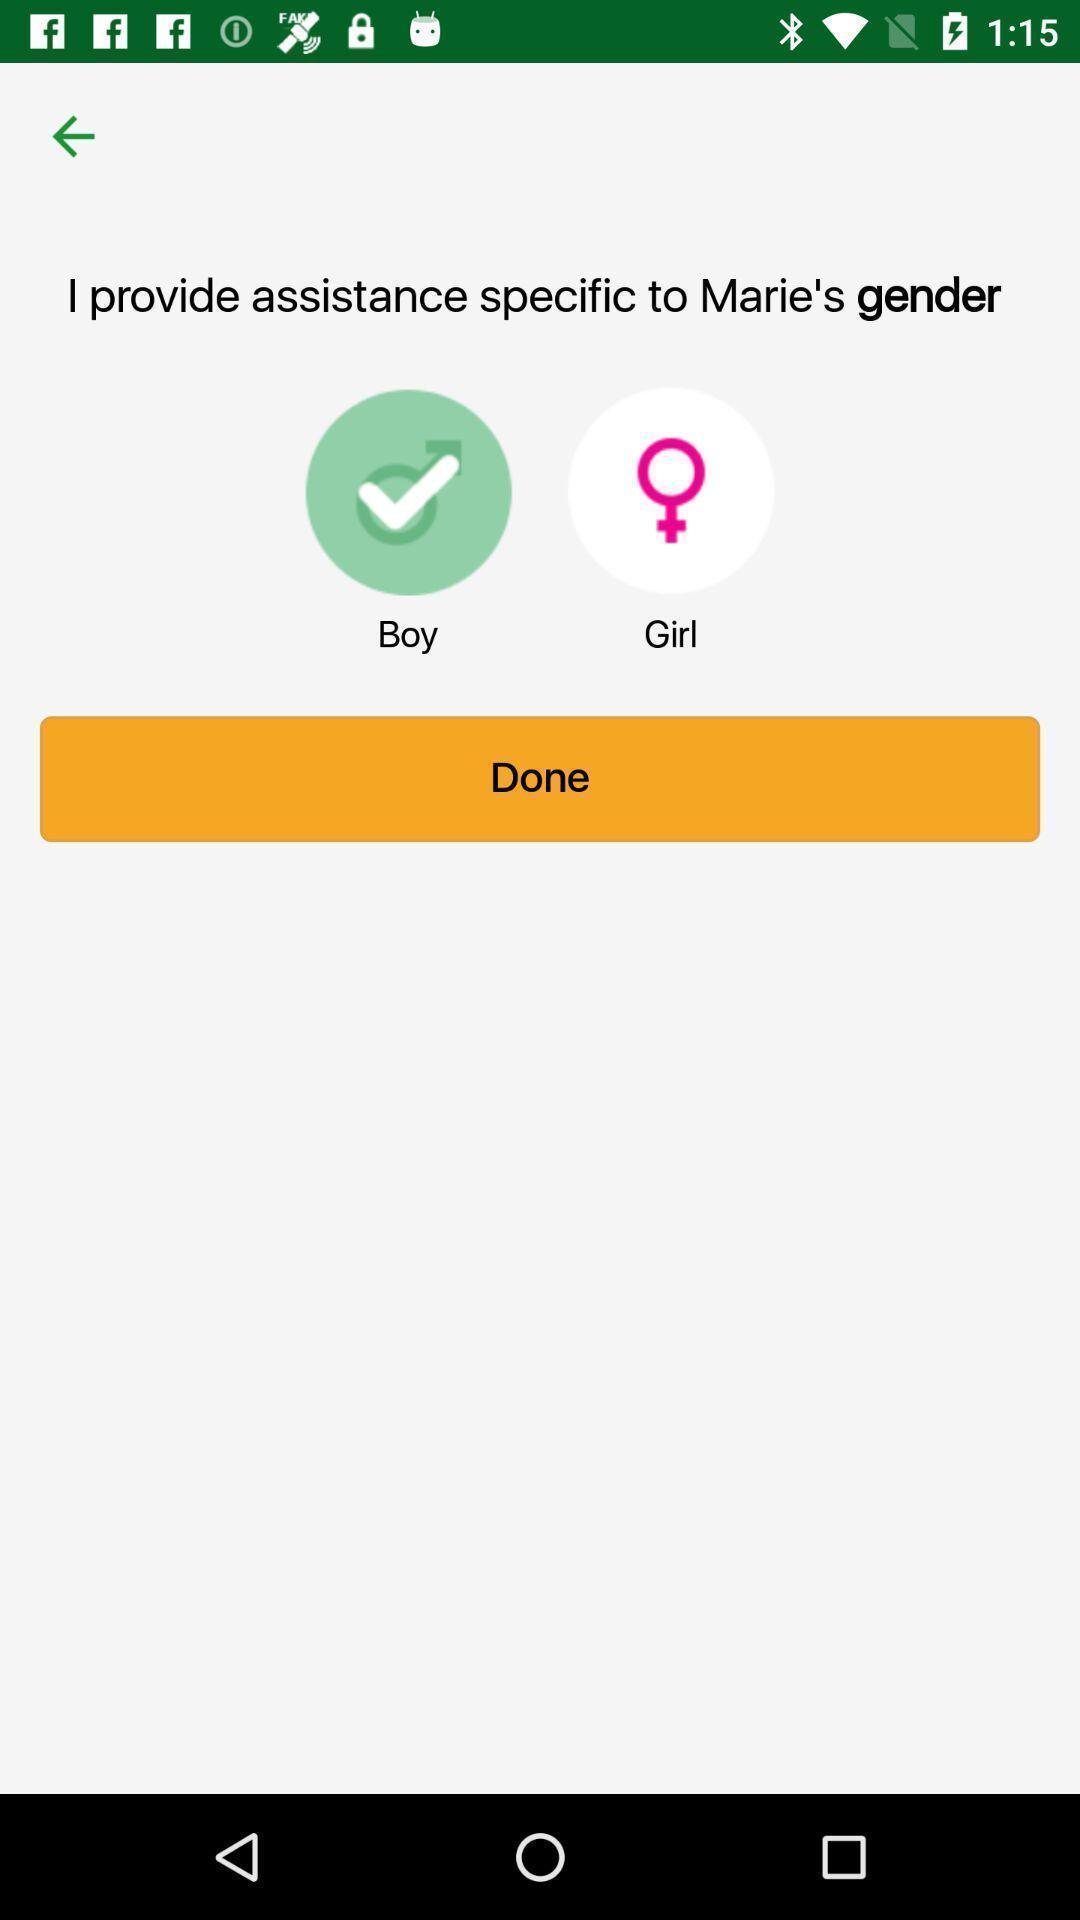Describe the visual elements of this screenshot. Page displaying to select a gender. 